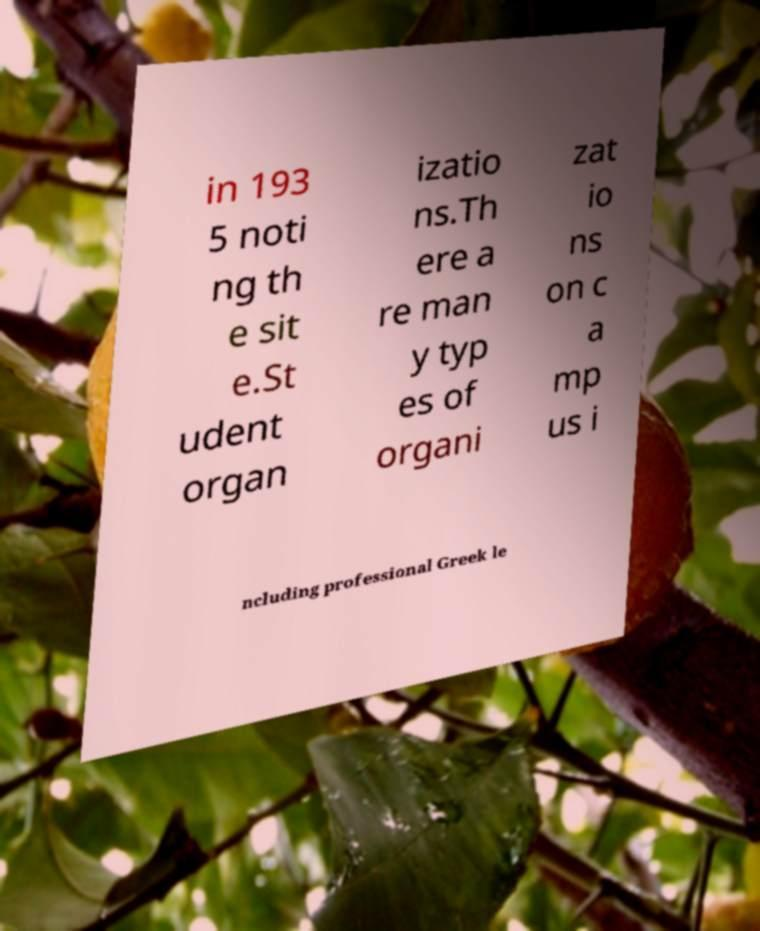What messages or text are displayed in this image? I need them in a readable, typed format. in 193 5 noti ng th e sit e.St udent organ izatio ns.Th ere a re man y typ es of organi zat io ns on c a mp us i ncluding professional Greek le 